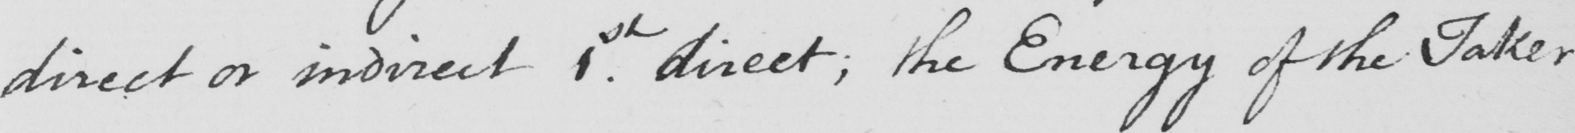Please provide the text content of this handwritten line. direct or indirect 1st direct ; the Energy of the Taker 